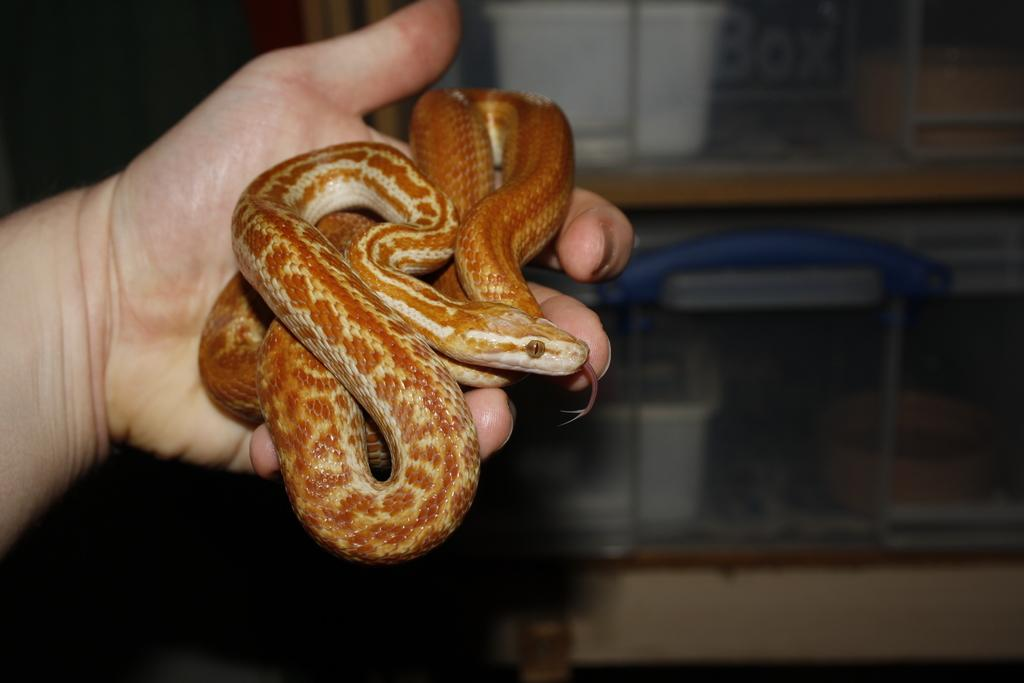What type of animal is being held in the person's hand in the image? There is a brown color snake in the person's hand. What can be seen in the background of the image? There is a wooden rack in the image. What color are the boxes placed on the wooden rack? White color boxes are placed on the wooden rack. What type of trees can be seen in the image? There are no trees visible in the image. What is the person's opinion about the drawer in the image? There is no drawer present in the image, so it is not possible to determine the person's opinion about it. 